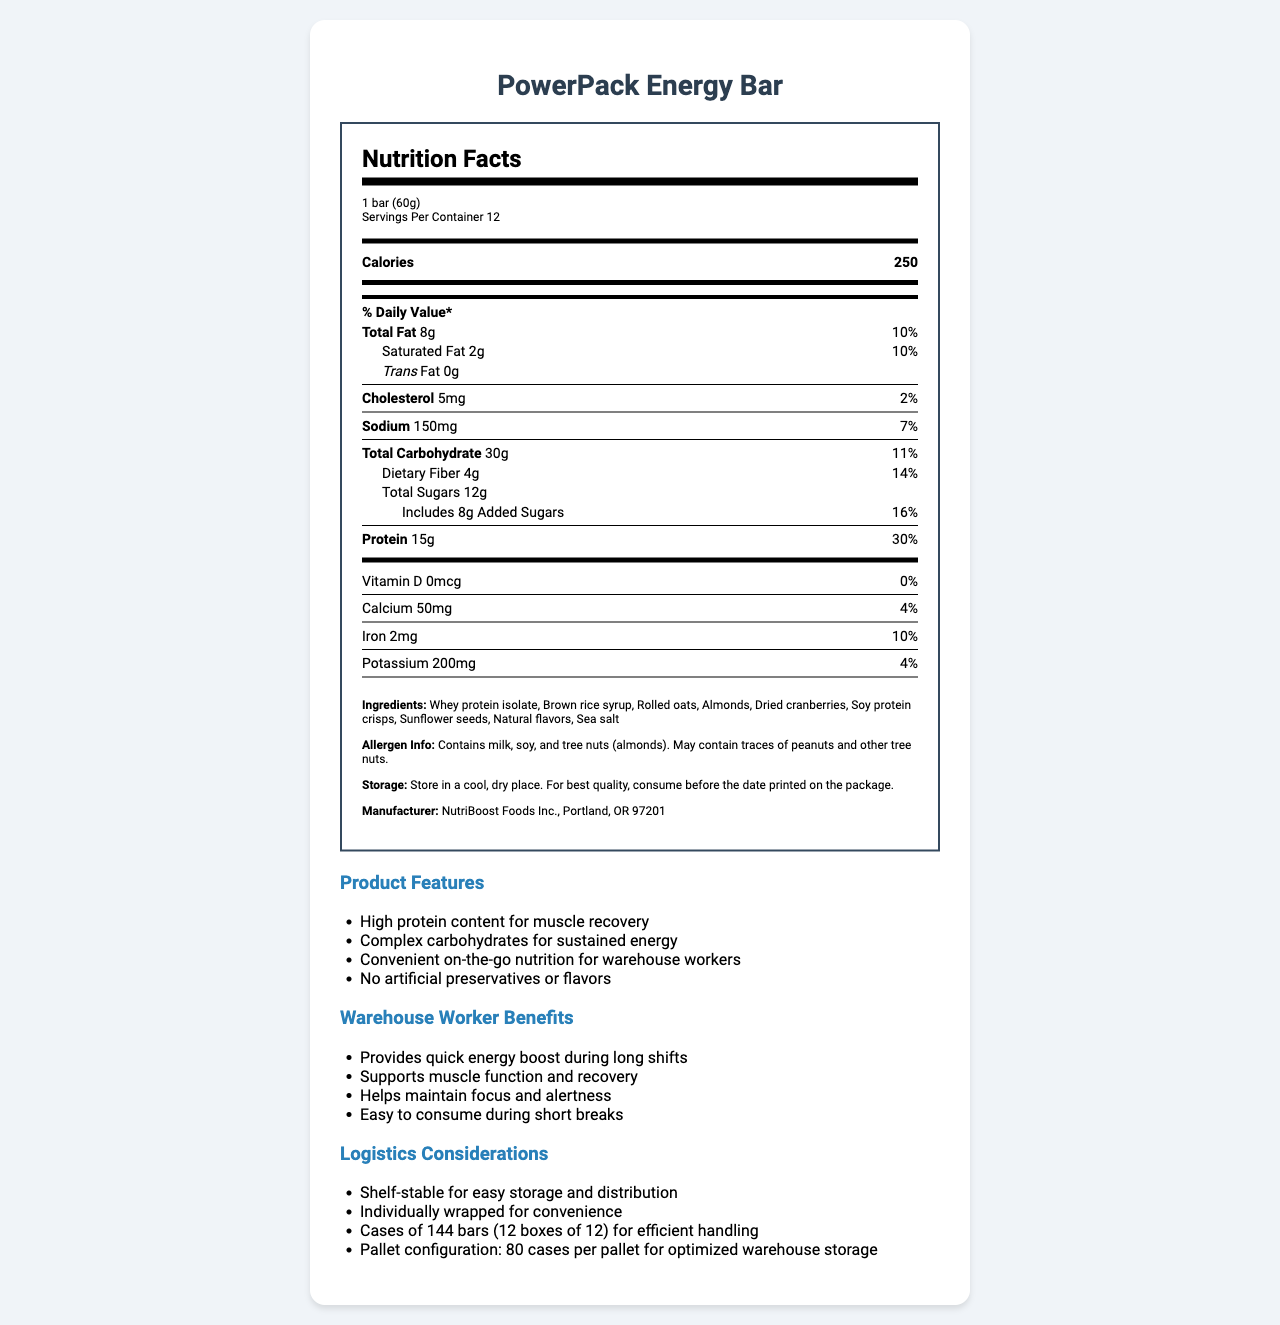what is the serving size of the PowerPack Energy Bar? The serving size is mentioned at the top of the nutrition facts label as "1 bar (60g)".
Answer: 1 bar (60g) how much protein is in one serving of the PowerPack Energy Bar? The protein content is listed under the nutrient information section as "Protein 15g".
Answer: 15g what percentage of the daily value of carbohydrates does one serving of the PowerPack Energy Bar provide? The daily value percentage for total carbohydrates is noted next to the carbohydrate amount as “11%”.
Answer: 11% what are the main ingredients of the PowerPack Energy Bar? The ingredients are listed in the ingredients section: "Whey protein isolate, Brown rice syrup, Rolled oats, Almonds, Dried cranberries, Soy protein crisps, Sunflower seeds, Natural flavors, Sea salt".
Answer: Whey protein isolate, Brown rice syrup, Rolled oats, Almonds, Dried cranberries, Soy protein crisps, Sunflower seeds, Natural flavors, Sea salt how should the PowerPack Energy Bar be stored? The storage instructions state: "Store in a cool, dry place. For best quality, consume before the date printed on the package.".
Answer: Store in a cool, dry place. For best quality, consume before the date printed on the package. which nutrient has the highest daily value percentage in the PowerPack Energy Bar? A. Total Fat B. Saturated Fat C. Dietary Fiber D. Protein The protein content has the highest daily value percentage at 30% as indicated in the daily value column.
Answer: D. Protein how many calories does the PowerPack Energy Bar contain per serving? A. 150 B. 200 C. 250 D. 300 The calorie content per serving is clearly shown as "Calories 250".
Answer: C. 250 how much sodium is in one serving of the PowerPack Energy Bar? The sodium content is listed under the nutrient information section as "Sodium 150mg".
Answer: 150mg are there any artificial preservatives or flavors in the PowerPack Energy Bar? One of the product features explicitly states "No artificial preservatives or flavors".
Answer: No is the PowerPack Energy Bar suitable for people with peanut allergies? The allergen information mentions "May contain traces of peanuts and other tree nuts," indicating it may not be suitable for people with peanut allergies.
Answer: No why is the PowerPack Energy Bar beneficial for warehouse workers? The warehouse worker benefits section lists the benefits clearly: "Provides quick energy boost during long shifts, supports muscle function and recovery, helps maintain focus and alertness, easy to consume during short breaks."
Answer: Provides quick energy boost during long shifts, supports muscle function and recovery, helps maintain focus and alertness, easy to consume during short breaks how many servings are there in one container of the PowerPack Energy Bar? The number of servings per container is given as "Servings Per Container 12".
Answer: 12 what is the total sugar content, including added sugars, in one serving of the PowerPack Energy Bar? The total sugar content is "12g" and the added sugars are listed as "8g".
Answer: 12g total sugars, 8g added sugars does the PowerPack Energy Bar contain any Vitamin D? The Vitamin D content is listed as "0mcg" with a daily value of "0%".
Answer: No who is the manufacturer of the PowerPack Energy Bar? The manufacturer information is stated at the end of the ingredients section: "NutriBoost Foods Inc., Portland, OR 97201".
Answer: NutriBoost Foods Inc., Portland, OR 97201 what is the total weight of a full container of PowerPack Energy Bars? The document does not provide the total weight of a full container of the bars.
Answer: Not enough information summarize the main features and benefits of the PowerPack Energy Bar for warehouse workers. This summary includes the main features and benefits, including high protein content, sustain energy, and muscle recovery support, along with convenience and allergen information.
Answer: The PowerPack Energy Bar is a high-protein snack designed to provide sustained energy and support muscle recovery for warehouse workers. It features complex carbohydrates, no artificial preservatives or flavors, and is easy to consume during short breaks. It is produced by NutriBoost Foods Inc. and contains allergens such as milk, soy, and tree nuts, with potential traces of peanuts. 